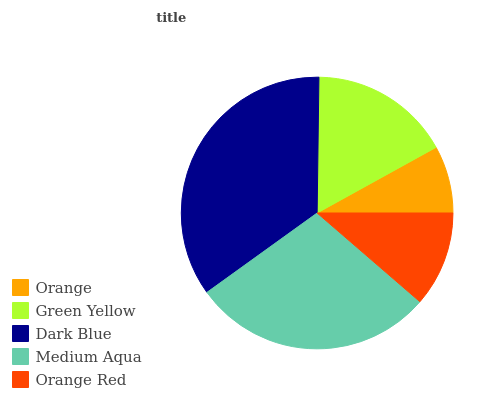Is Orange the minimum?
Answer yes or no. Yes. Is Dark Blue the maximum?
Answer yes or no. Yes. Is Green Yellow the minimum?
Answer yes or no. No. Is Green Yellow the maximum?
Answer yes or no. No. Is Green Yellow greater than Orange?
Answer yes or no. Yes. Is Orange less than Green Yellow?
Answer yes or no. Yes. Is Orange greater than Green Yellow?
Answer yes or no. No. Is Green Yellow less than Orange?
Answer yes or no. No. Is Green Yellow the high median?
Answer yes or no. Yes. Is Green Yellow the low median?
Answer yes or no. Yes. Is Orange the high median?
Answer yes or no. No. Is Medium Aqua the low median?
Answer yes or no. No. 